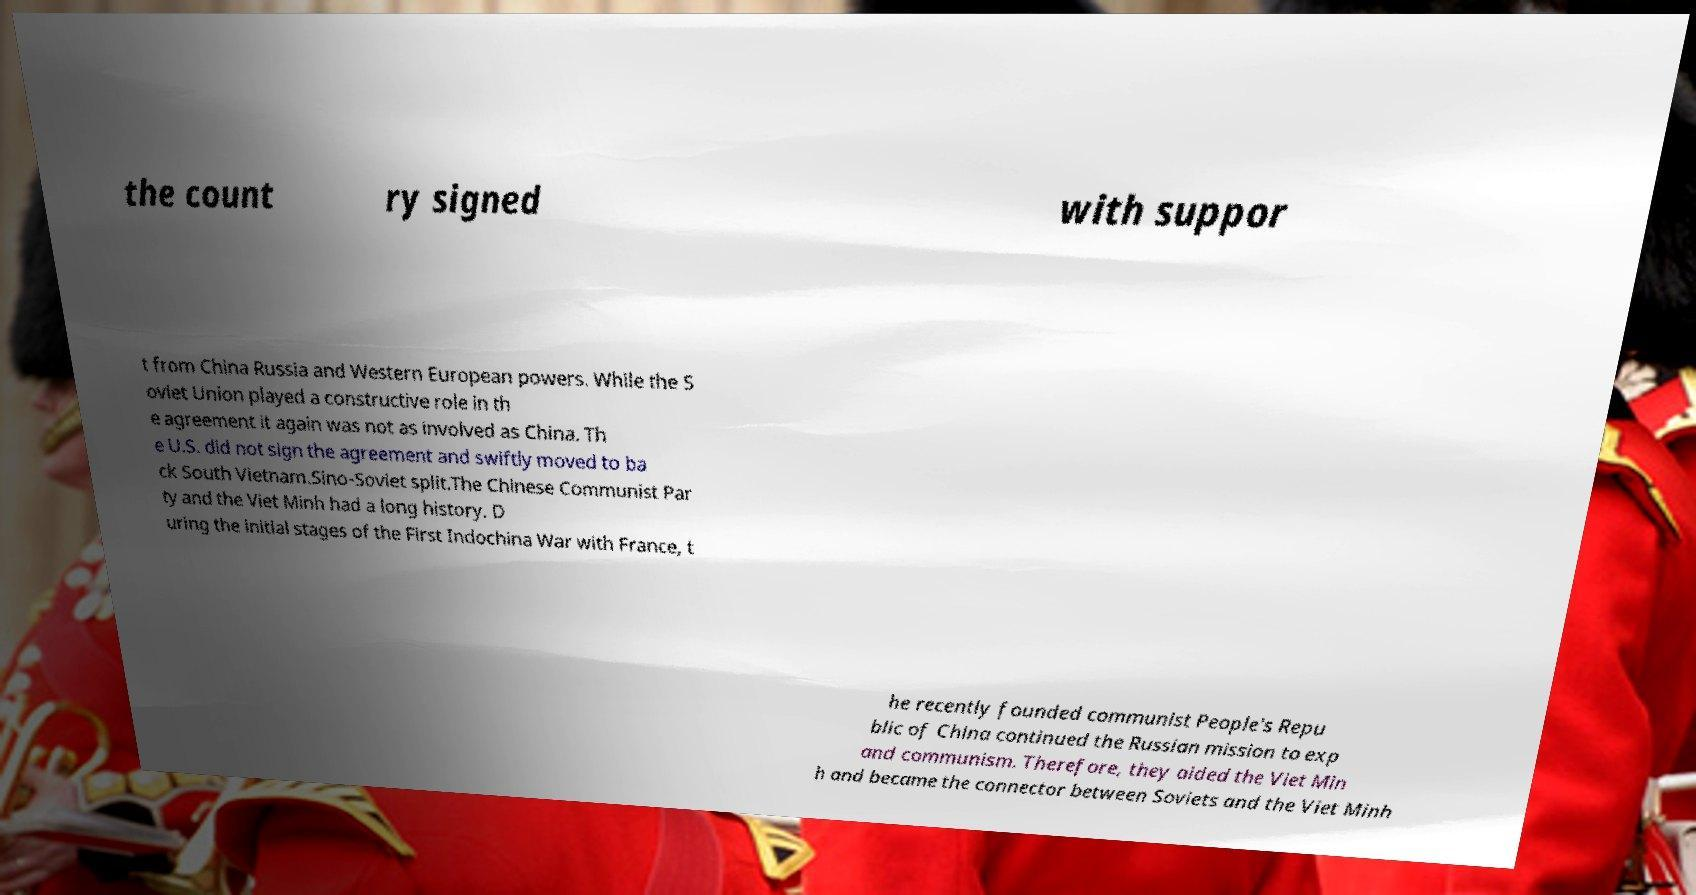Please identify and transcribe the text found in this image. the count ry signed with suppor t from China Russia and Western European powers. While the S oviet Union played a constructive role in th e agreement it again was not as involved as China. Th e U.S. did not sign the agreement and swiftly moved to ba ck South Vietnam.Sino-Soviet split.The Chinese Communist Par ty and the Viet Minh had a long history. D uring the initial stages of the First Indochina War with France, t he recently founded communist People's Repu blic of China continued the Russian mission to exp and communism. Therefore, they aided the Viet Min h and became the connector between Soviets and the Viet Minh 